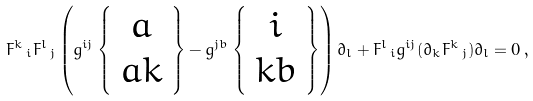<formula> <loc_0><loc_0><loc_500><loc_500>F ^ { k } \, _ { i } F ^ { l } \, _ { j } \left ( g ^ { i j } \left \{ \begin{array} { c } { a } \\ { a k } \end{array} \right \} - g ^ { j b } \left \{ \begin{array} { c } { i } \\ { k b } \end{array} \right \} \right ) \partial _ { l } + F ^ { l } \, _ { i } g ^ { i j } ( \partial _ { k } F ^ { k } \, _ { j } ) \partial _ { l } = 0 \, ,</formula> 